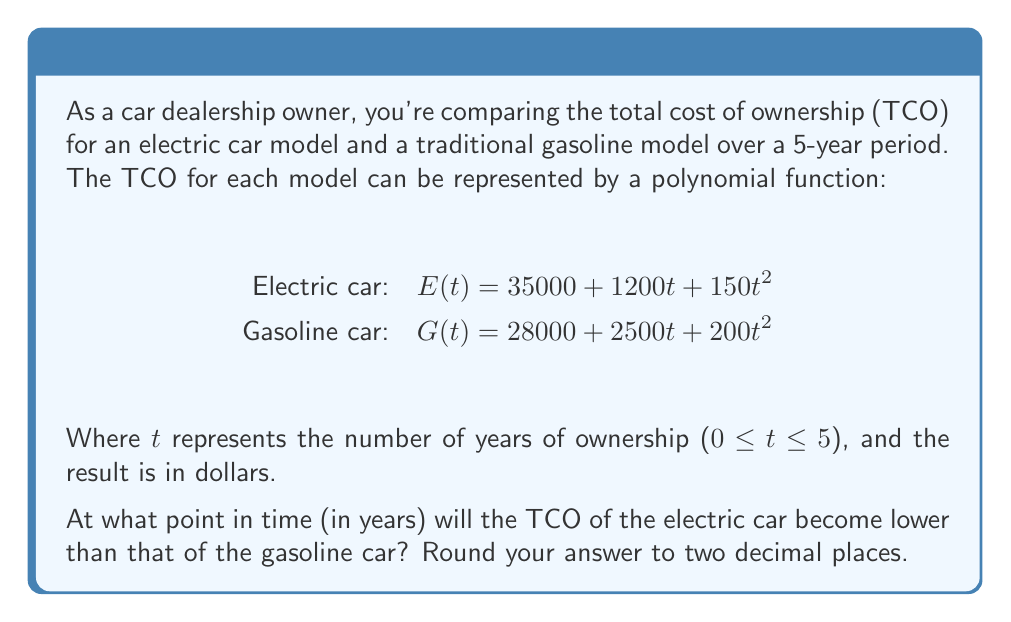Teach me how to tackle this problem. To find the point where the TCO of the electric car becomes lower than the gasoline car, we need to set the two functions equal to each other and solve for t:

$$E(t) = G(t)$$
$$35000 + 1200t + 150t^2 = 28000 + 2500t + 200t^2$$

Simplifying:
$$7000 - 1300t - 50t^2 = 0$$

This is a quadratic equation. We can solve it using the quadratic formula:

$$t = \frac{-b \pm \sqrt{b^2 - 4ac}}{2a}$$

Where $a = -50$, $b = -1300$, and $c = 7000$

Substituting these values:

$$t = \frac{1300 \pm \sqrt{(-1300)^2 - 4(-50)(7000)}}{2(-50)}$$
$$t = \frac{1300 \pm \sqrt{1690000 + 1400000}}{-100}$$
$$t = \frac{1300 \pm \sqrt{3090000}}{-100}$$
$$t = \frac{1300 \pm 1757.84}{-100}$$

This gives us two solutions:
$$t_1 = \frac{1300 + 1757.84}{-100} = -30.5784$$
$$t_2 = \frac{1300 - 1757.84}{-100} = 4.5784$$

Since time cannot be negative in this context, and we're limited to 5 years, the relevant solution is 4.5784 years.
Answer: The TCO of the electric car will become lower than that of the gasoline car after approximately 4.58 years. 